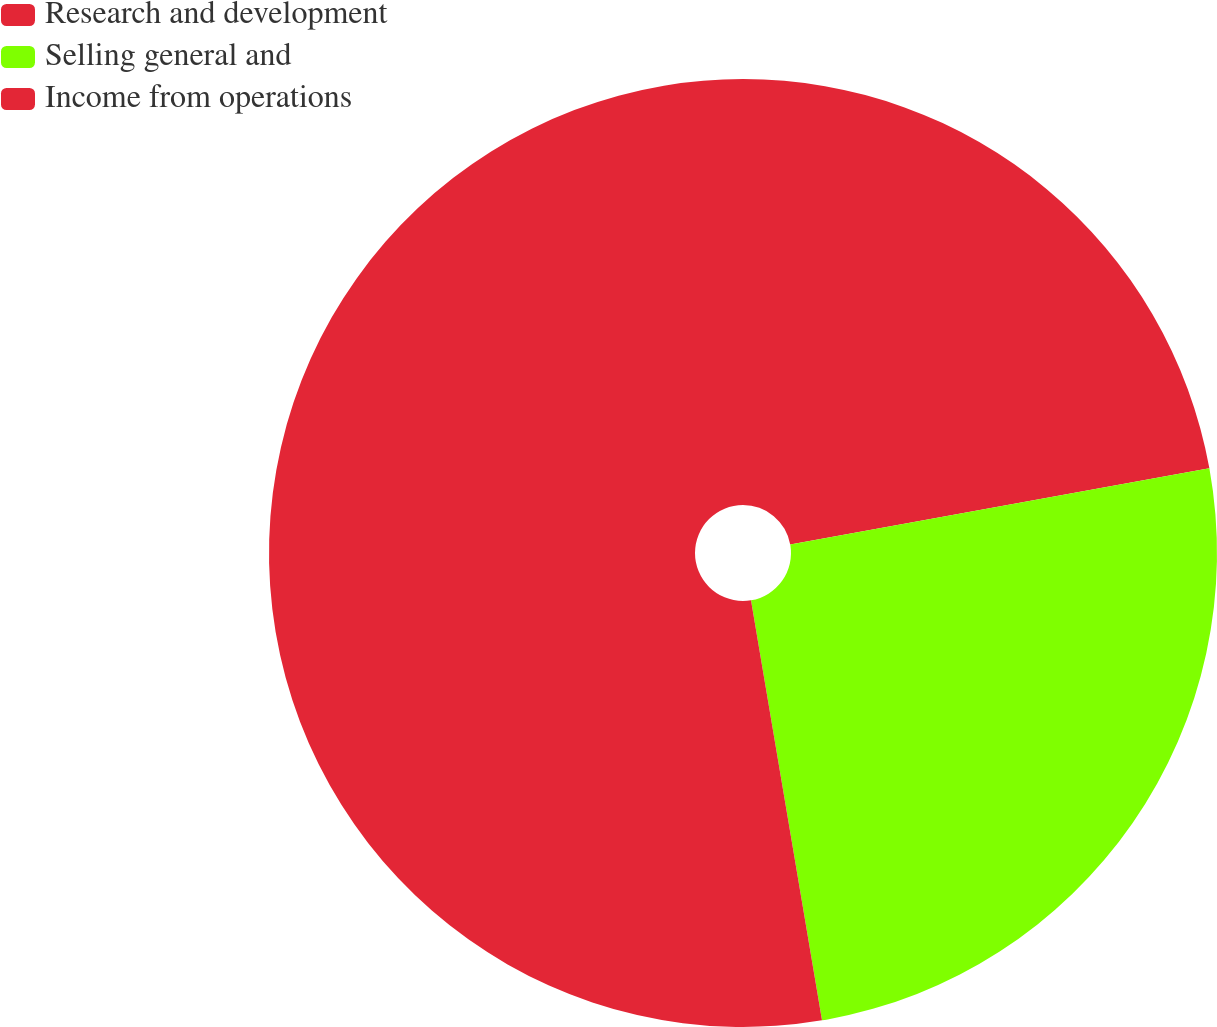<chart> <loc_0><loc_0><loc_500><loc_500><pie_chart><fcel>Research and development<fcel>Selling general and<fcel>Income from operations<nl><fcel>22.14%<fcel>25.19%<fcel>52.66%<nl></chart> 